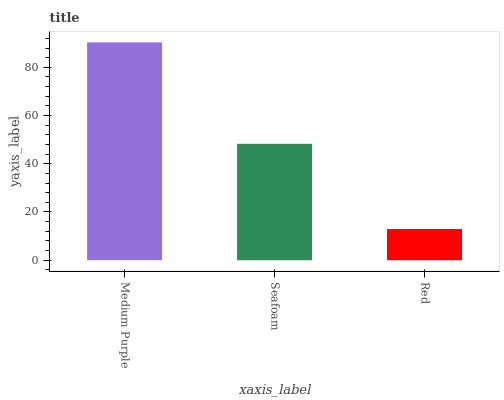Is Red the minimum?
Answer yes or no. Yes. Is Medium Purple the maximum?
Answer yes or no. Yes. Is Seafoam the minimum?
Answer yes or no. No. Is Seafoam the maximum?
Answer yes or no. No. Is Medium Purple greater than Seafoam?
Answer yes or no. Yes. Is Seafoam less than Medium Purple?
Answer yes or no. Yes. Is Seafoam greater than Medium Purple?
Answer yes or no. No. Is Medium Purple less than Seafoam?
Answer yes or no. No. Is Seafoam the high median?
Answer yes or no. Yes. Is Seafoam the low median?
Answer yes or no. Yes. Is Red the high median?
Answer yes or no. No. Is Medium Purple the low median?
Answer yes or no. No. 